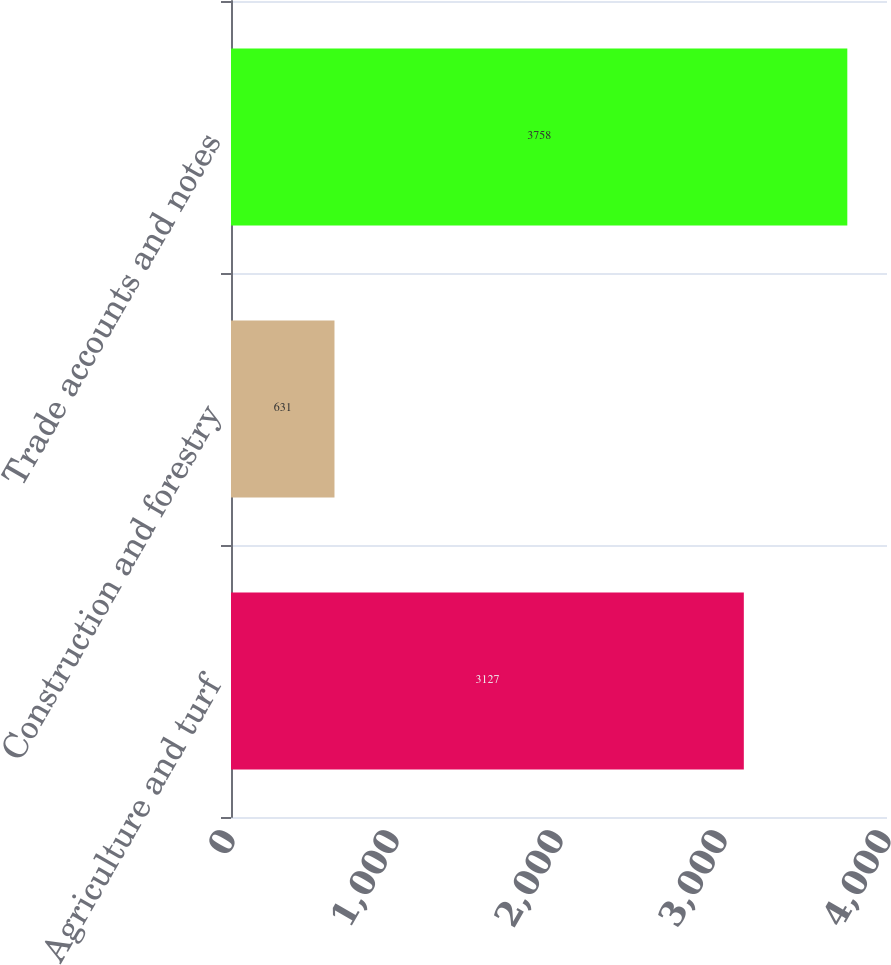<chart> <loc_0><loc_0><loc_500><loc_500><bar_chart><fcel>Agriculture and turf<fcel>Construction and forestry<fcel>Trade accounts and notes<nl><fcel>3127<fcel>631<fcel>3758<nl></chart> 